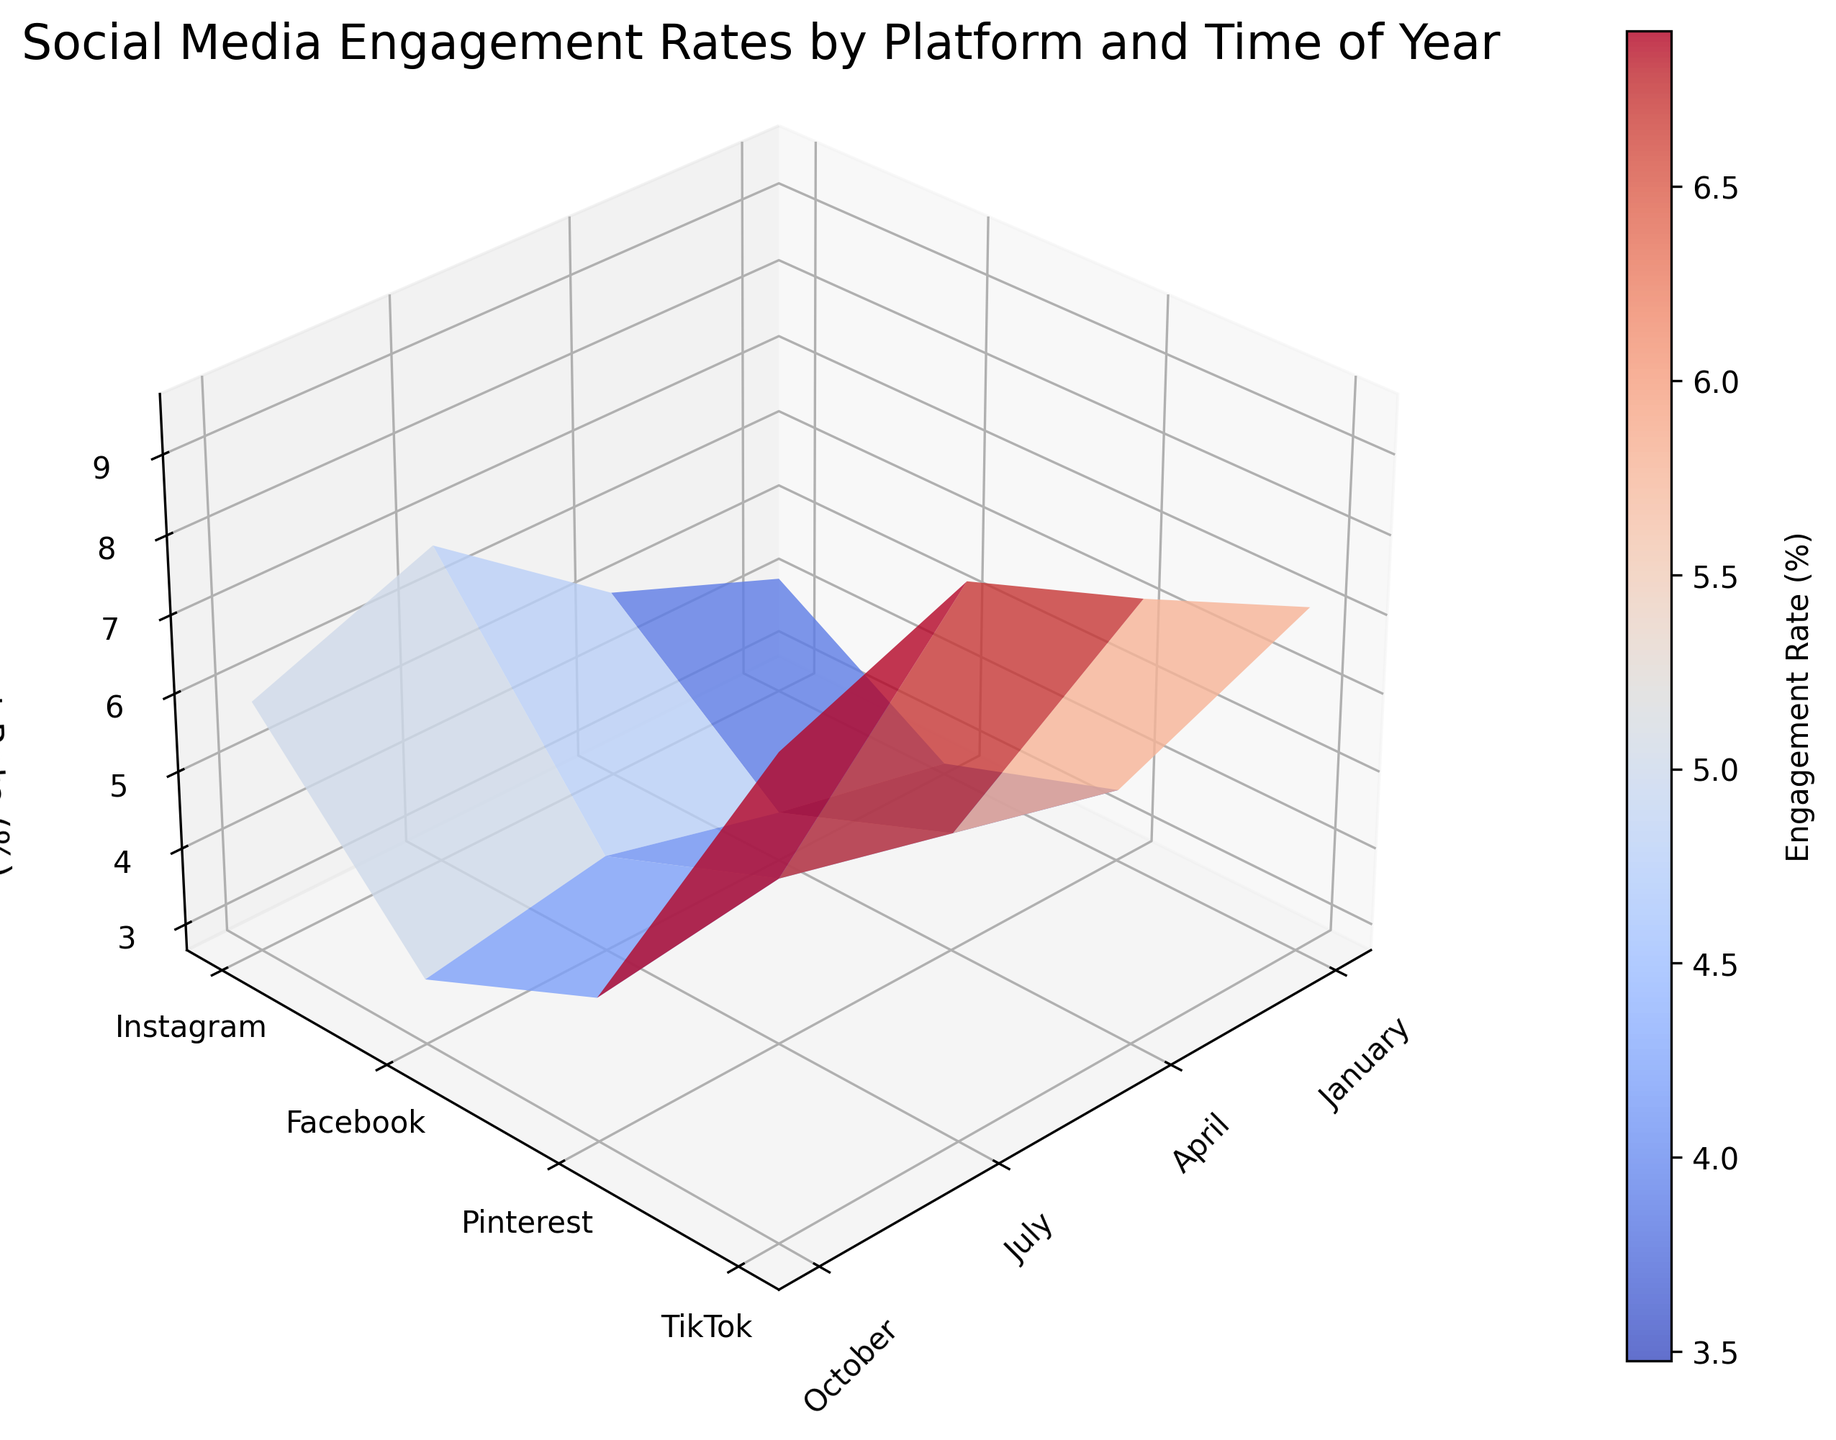What's the title of the figure? The title can be found at the top of the plot. It reads "Social Media Engagement Rates by Platform and Time of Year."
Answer: Social Media Engagement Rates by Platform and Time of Year Which platform has the highest engagement rate in October? Look at the October section on the x-axis and identify the highest point on the surface. The highest engagement rate in October is on the TikTok platform.
Answer: TikTok What is the engagement rate on Facebook in April? Locate Facebook on the y-axis and April on the x-axis, and then see where they intersect on the surface. The engagement rate there is 3.3%.
Answer: 3.3% How does Instagram's engagement rate in July compare to Pinterest's in April? Identify the points for Instagram in July (6.8%) and Pinterest in April (4.2%). Compare the two values; Instagram’s engagement rate in July is higher.
Answer: Instagram's is higher Which month shows the highest engagement rate for TikTok? Look at all the points for TikTok by scanning its corresponding row on the y-axis. The highest value is 9.6% in July.
Answer: July Can you list the engagement rates for Pinterest across all months? Find Pinterest on the y-axis and read the corresponding values across January, April, July, and October on the surface plot. The values are 3.6%, 4.2%, 4.8%, and 4.5% respectively.
Answer: 3.6%, 4.2%, 4.8%, 4.5% What is the overall trend of engagement rates for TikTok from January to October? Observe the surface plot for TikTok from January to October. The engagement rate increases from January (7.1%) to July (9.6%) and decreases slightly in October (8.7%).
Answer: Rises then slightly falls How does the engagement rate of Instagram in January compare to Facebook in July? Identify the values for Instagram in January (4.2%) and Facebook in July (3.9%). Compare these two values; Instagram in January has a higher rate.
Answer: Instagram's is higher What is the average engagement rate for Facebook across all months? Add the engagement rates for Facebook (2.8%, 3.3%, 3.9%, 3.5%) and divide by the number of months (4). (2.8 + 3.3 + 3.9 + 3.5)/4 = 3.375%.
Answer: 3.375% Which platform shows the most seasonal variation in engagement rates? Compare the range of engagement rates across all platforms throughout the year. TikTok shows the most variation with rates ranging from 7.1% in January to 9.6% in July.
Answer: TikTok 